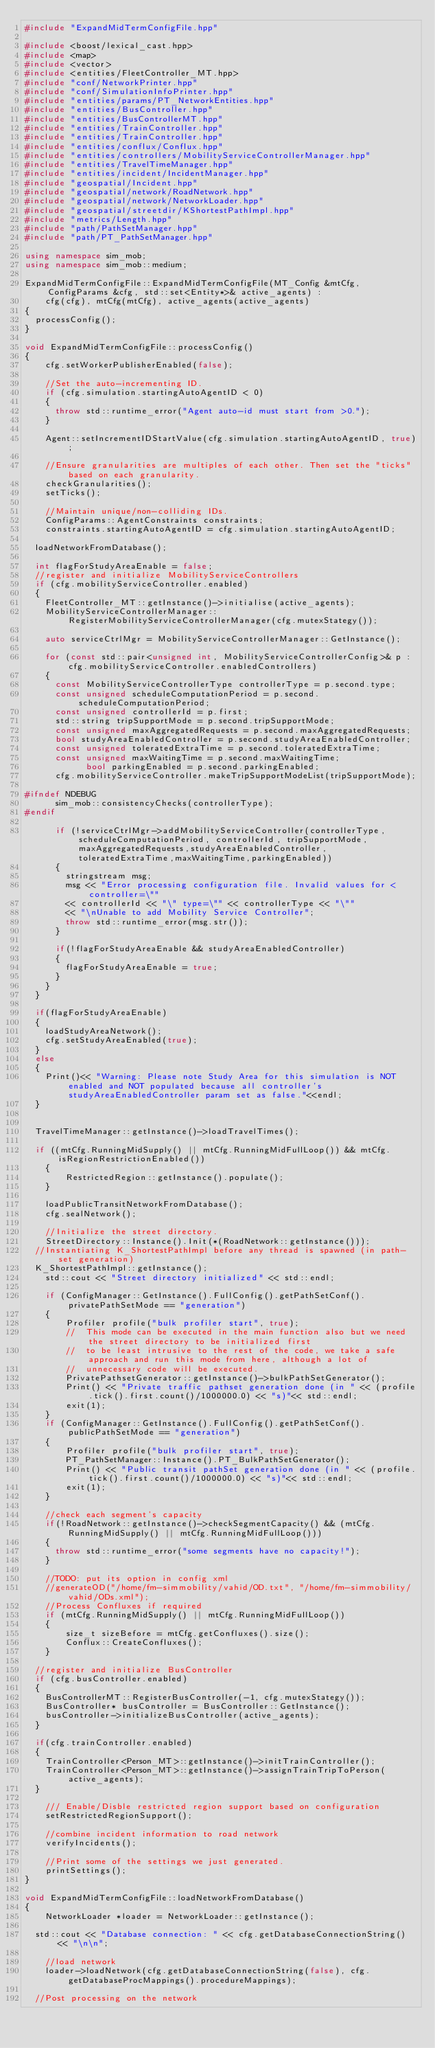<code> <loc_0><loc_0><loc_500><loc_500><_C++_>#include "ExpandMidTermConfigFile.hpp"

#include <boost/lexical_cast.hpp>
#include <map>
#include <vector>
#include <entities/FleetController_MT.hpp>
#include "conf/NetworkPrinter.hpp"
#include "conf/SimulationInfoPrinter.hpp"
#include "entities/params/PT_NetworkEntities.hpp"
#include "entities/BusController.hpp"
#include "entities/BusControllerMT.hpp"
#include "entities/TrainController.hpp"
#include "entities/TrainController.hpp"
#include "entities/conflux/Conflux.hpp"
#include "entities/controllers/MobilityServiceControllerManager.hpp"
#include "entities/TravelTimeManager.hpp"
#include "entities/incident/IncidentManager.hpp"
#include "geospatial/Incident.hpp"
#include "geospatial/network/RoadNetwork.hpp"
#include "geospatial/network/NetworkLoader.hpp"
#include "geospatial/streetdir/KShortestPathImpl.hpp"
#include "metrics/Length.hpp"
#include "path/PathSetManager.hpp"
#include "path/PT_PathSetManager.hpp"

using namespace sim_mob;
using namespace sim_mob::medium;

ExpandMidTermConfigFile::ExpandMidTermConfigFile(MT_Config &mtCfg, ConfigParams &cfg, std::set<Entity*>& active_agents) :
		cfg(cfg), mtCfg(mtCfg), active_agents(active_agents)
{
	processConfig();
}

void ExpandMidTermConfigFile::processConfig()
{
    cfg.setWorkerPublisherEnabled(false);

    //Set the auto-incrementing ID.
    if (cfg.simulation.startingAutoAgentID < 0)
    {
	    throw std::runtime_error("Agent auto-id must start from >0.");
    }

    Agent::setIncrementIDStartValue(cfg.simulation.startingAutoAgentID, true);

    //Ensure granularities are multiples of each other. Then set the "ticks" based on each granularity.
    checkGranularities();
    setTicks();

    //Maintain unique/non-colliding IDs.
    ConfigParams::AgentConstraints constraints;
    constraints.startingAutoAgentID = cfg.simulation.startingAutoAgentID;

	loadNetworkFromDatabase();

	int flagForStudyAreaEnable = false;
	//register and initialize MobilityServiceControllers
	if (cfg.mobilityServiceController.enabled)
	{
		FleetController_MT::getInstance()->initialise(active_agents);
		MobilityServiceControllerManager::RegisterMobilityServiceControllerManager(cfg.mutexStategy());

		auto serviceCtrlMgr = MobilityServiceControllerManager::GetInstance();

		for (const std::pair<unsigned int, MobilityServiceControllerConfig>& p : cfg.mobilityServiceController.enabledControllers)
		{
			const MobilityServiceControllerType controllerType = p.second.type;
			const unsigned scheduleComputationPeriod = p.second.scheduleComputationPeriod;
			const unsigned controllerId = p.first;
			std::string tripSupportMode = p.second.tripSupportMode;
			const unsigned maxAggregatedRequests = p.second.maxAggregatedRequests;
			bool studyAreaEnabledController = p.second.studyAreaEnabledController;
			const unsigned toleratedExtraTime = p.second.toleratedExtraTime;
			const unsigned maxWaitingTime = p.second.maxWaitingTime;
            bool parkingEnabled = p.second.parkingEnabled;
			cfg.mobilityServiceController.makeTripSupportModeList(tripSupportMode);

#ifndef NDEBUG
			sim_mob::consistencyChecks(controllerType);
#endif

			if (!serviceCtrlMgr->addMobilityServiceController(controllerType, scheduleComputationPeriod, controllerId, tripSupportMode,maxAggregatedRequests,studyAreaEnabledController,toleratedExtraTime,maxWaitingTime,parkingEnabled))
			{
				stringstream msg;
				msg << "Error processing configuration file. Invalid values for <controller=\""
				<< controllerId << "\" type=\"" << controllerType << "\""
				<< "\nUnable to add Mobility Service Controller";
				throw std::runtime_error(msg.str());
			}

			if(!flagForStudyAreaEnable && studyAreaEnabledController)
			{
				flagForStudyAreaEnable = true;
			}
		}
	}

	if(flagForStudyAreaEnable)
	{
		loadStudyAreaNetwork();
		cfg.setStudyAreaEnabled(true);
	}
	else
	{
		Print()<< "Warning: Please note Study Area for this simulation is NOT enabled and NOT populated because all controller's studyAreaEnabledController param set as false."<<endl;
	}


	TravelTimeManager::getInstance()->loadTravelTimes();

	if ((mtCfg.RunningMidSupply() || mtCfg.RunningMidFullLoop()) && mtCfg.isRegionRestrictionEnabled())
    {
        RestrictedRegion::getInstance().populate();
    }

    loadPublicTransitNetworkFromDatabase();
    cfg.sealNetwork();

    //Initialize the street directory.
    StreetDirectory::Instance().Init(*(RoadNetwork::getInstance()));
	//Instantiating K_ShortestPathImpl before any thread is spawned (in path-set generation)
	K_ShortestPathImpl::getInstance();
    std::cout << "Street directory initialized" << std::endl;

    if (ConfigManager::GetInstance().FullConfig().getPathSetConf().privatePathSetMode == "generation")
    {
        Profiler profile("bulk profiler start", true);
        //	This mode can be executed in the main function also but we need the street directory to be initialized first
        //	to be least intrusive to the rest of the code, we take a safe approach and run this mode from here, although a lot of
        //	unnecessary code will be executed.
        PrivatePathsetGenerator::getInstance()->bulkPathSetGenerator();
        Print() << "Private traffic pathset generation done (in " << (profile.tick().first.count()/1000000.0) << "s)"<< std::endl;
        exit(1);
    }
    if (ConfigManager::GetInstance().FullConfig().getPathSetConf().publicPathSetMode == "generation")
    {
        Profiler profile("bulk profiler start", true);
        PT_PathSetManager::Instance().PT_BulkPathSetGenerator();
        Print() << "Public transit pathSet generation done (in " << (profile.tick().first.count()/1000000.0) << "s)"<< std::endl;
        exit(1);
    }

    //check each segment's capacity
    if(!RoadNetwork::getInstance()->checkSegmentCapacity() && (mtCfg.RunningMidSupply() || mtCfg.RunningMidFullLoop()))
    {
    	throw std::runtime_error("some segments have no capacity!");
    }

    //TODO: put its option in config xml
    //generateOD("/home/fm-simmobility/vahid/OD.txt", "/home/fm-simmobility/vahid/ODs.xml");
    //Process Confluxes if required
    if (mtCfg.RunningMidSupply() || mtCfg.RunningMidFullLoop())
    {
        size_t sizeBefore = mtCfg.getConfluxes().size();
        Conflux::CreateConfluxes();
    }

	//register and initialize BusController
	if (cfg.busController.enabled)
	{
		BusControllerMT::RegisterBusController(-1, cfg.mutexStategy());
		BusController* busController = BusController::GetInstance();
		busController->initializeBusController(active_agents);
	}

	if(cfg.trainController.enabled)
	{
		TrainController<Person_MT>::getInstance()->initTrainController();
		TrainController<Person_MT>::getInstance()->assignTrainTripToPerson(active_agents);
	}

    /// Enable/Disble restricted region support based on configuration
    setRestrictedRegionSupport();

    //combine incident information to road network
    verifyIncidents();

    //Print some of the settings we just generated.
    printSettings();
}

void ExpandMidTermConfigFile::loadNetworkFromDatabase()
{
    NetworkLoader *loader = NetworkLoader::getInstance();

	std::cout << "Database connection: " << cfg.getDatabaseConnectionString() << "\n\n";

    //load network
    loader->loadNetwork(cfg.getDatabaseConnectionString(false), cfg.getDatabaseProcMappings().procedureMappings);

	//Post processing on the network</code> 